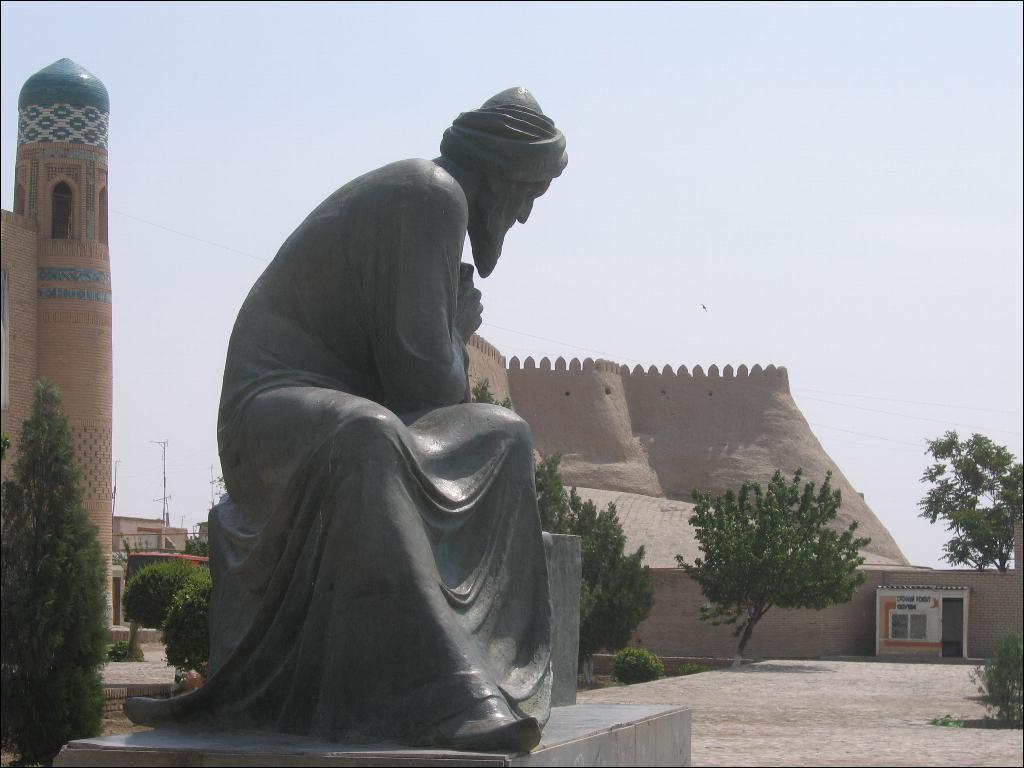Describe this image in one or two sentences. In a given image I can see a sculpture, architectural, plants, pole and in the background I can see the sky. 